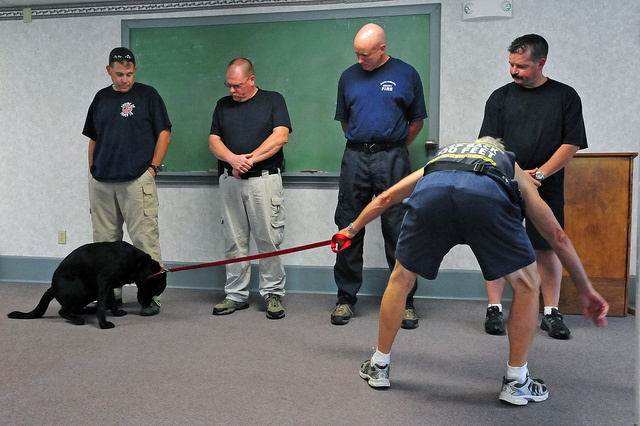Describe the objects in this image and their specific colors. I can see people in gray, black, brown, and darkgray tones, people in gray, black, navy, and darkblue tones, people in gray, black, darkgray, and brown tones, people in gray, black, and darkgray tones, and people in gray, black, brown, and maroon tones in this image. 